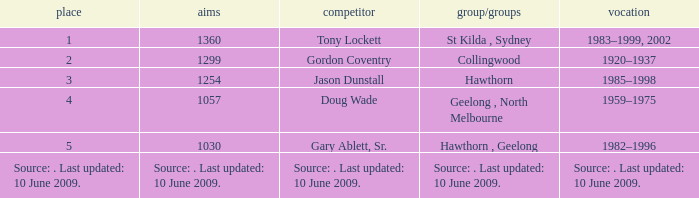What is the rank of player Jason Dunstall? 3.0. 